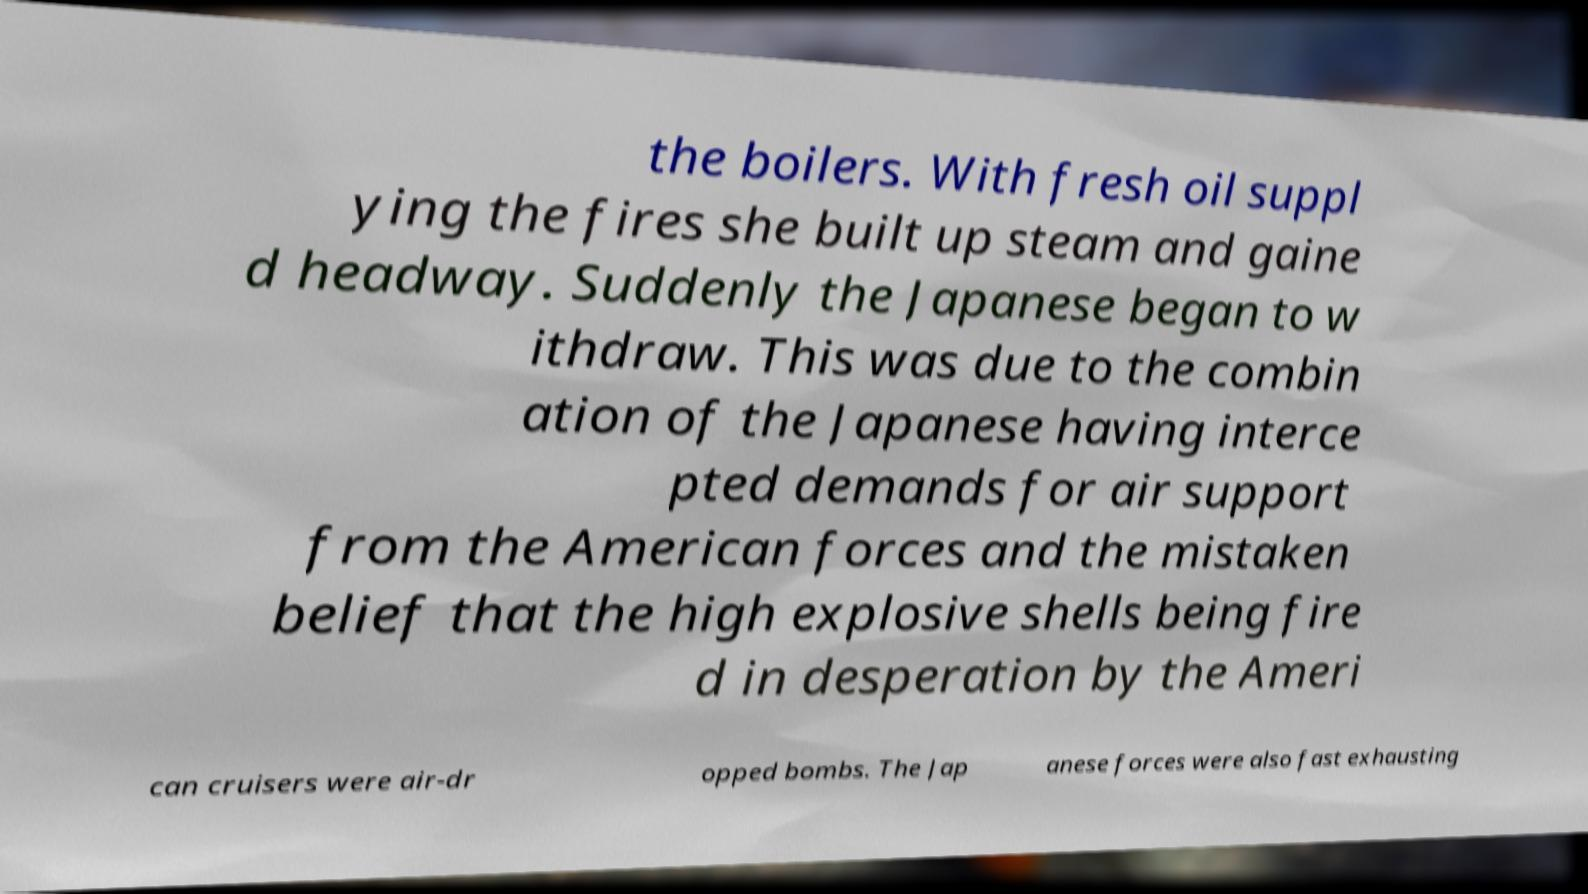There's text embedded in this image that I need extracted. Can you transcribe it verbatim? the boilers. With fresh oil suppl ying the fires she built up steam and gaine d headway. Suddenly the Japanese began to w ithdraw. This was due to the combin ation of the Japanese having interce pted demands for air support from the American forces and the mistaken belief that the high explosive shells being fire d in desperation by the Ameri can cruisers were air-dr opped bombs. The Jap anese forces were also fast exhausting 